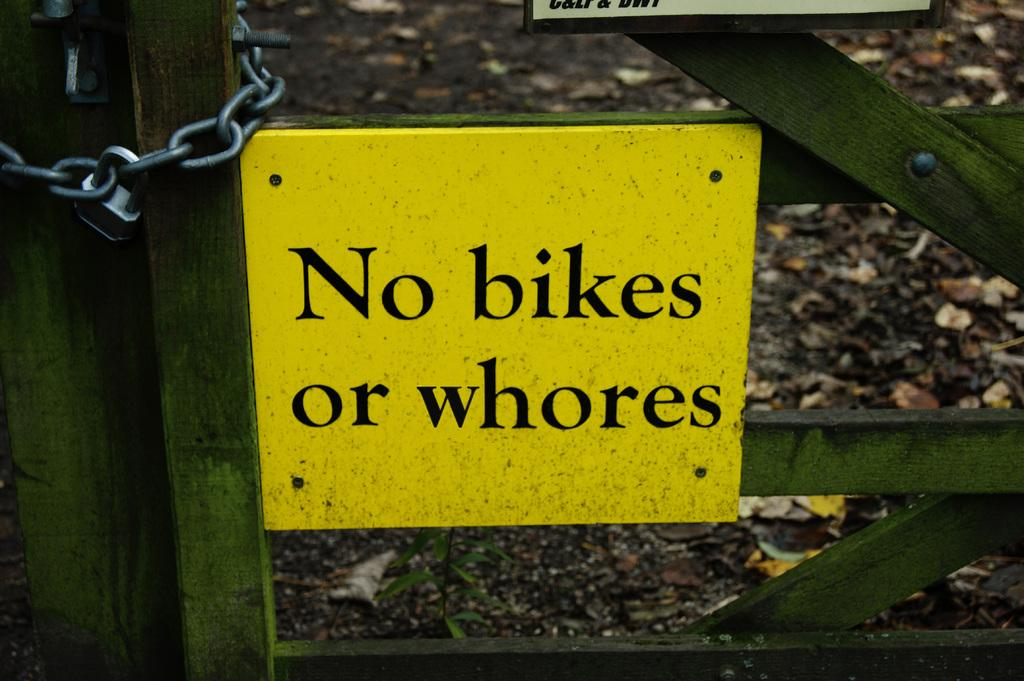What type of fence is visible in the image? There is a wooden fence in the image. What is attached to the wooden fence? There is a yellow color board on the fence. What other object can be seen in the image? There is a chain in the image. Where is the lock located in the image? There is a lock in the image, specifically on the left side. Can you see any icicles hanging from the wooden fence in the image? There are no icicles visible in the image. Is there a cat sitting on the yellow color board in the image? There is no cat present in the image. 